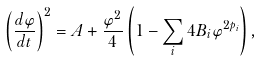<formula> <loc_0><loc_0><loc_500><loc_500>\left ( \frac { d \varphi } { d t } \right ) ^ { 2 } = A + \frac { \varphi ^ { 2 } } { 4 } \left ( 1 - \sum _ { i } 4 B _ { i } \varphi ^ { 2 p _ { i } } \right ) ,</formula> 